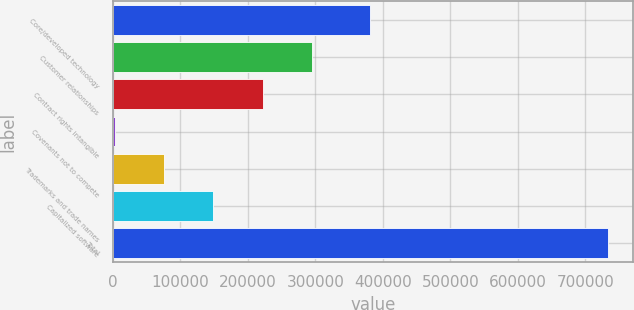Convert chart to OTSL. <chart><loc_0><loc_0><loc_500><loc_500><bar_chart><fcel>Core/developed technology<fcel>Customer relationships<fcel>Contract rights intangible<fcel>Covenants not to compete<fcel>Trademarks and trade names<fcel>Capitalized software<fcel>Total<nl><fcel>380724<fcel>295238<fcel>222061<fcel>2530<fcel>75707.1<fcel>148884<fcel>734301<nl></chart> 